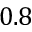Convert formula to latex. <formula><loc_0><loc_0><loc_500><loc_500>0 . 8</formula> 